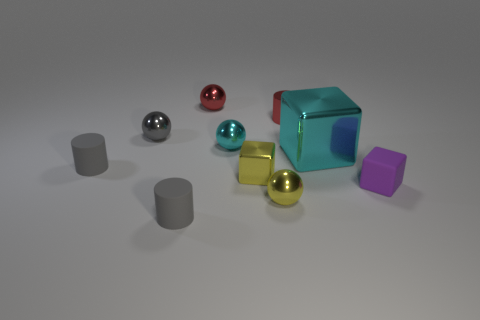What might be the function of these objects in a real-world setting? These objects appear to be simplistic representations, perhaps used as part of a design or visualization exercise. They could be metaphors for real-world items in an educational context, where shapes and materials are explored, or components in a digital art piece. 